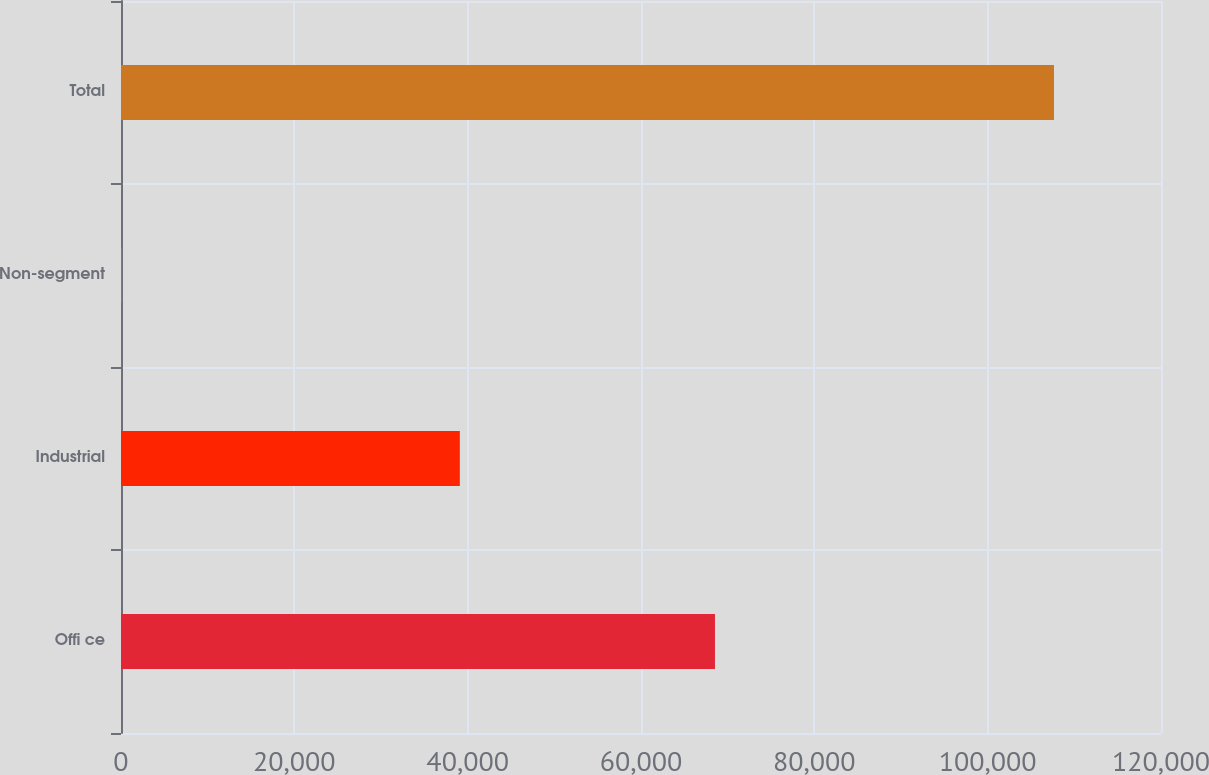<chart> <loc_0><loc_0><loc_500><loc_500><bar_chart><fcel>Offi ce<fcel>Industrial<fcel>Non-segment<fcel>Total<nl><fcel>68535<fcel>39096<fcel>22<fcel>107653<nl></chart> 